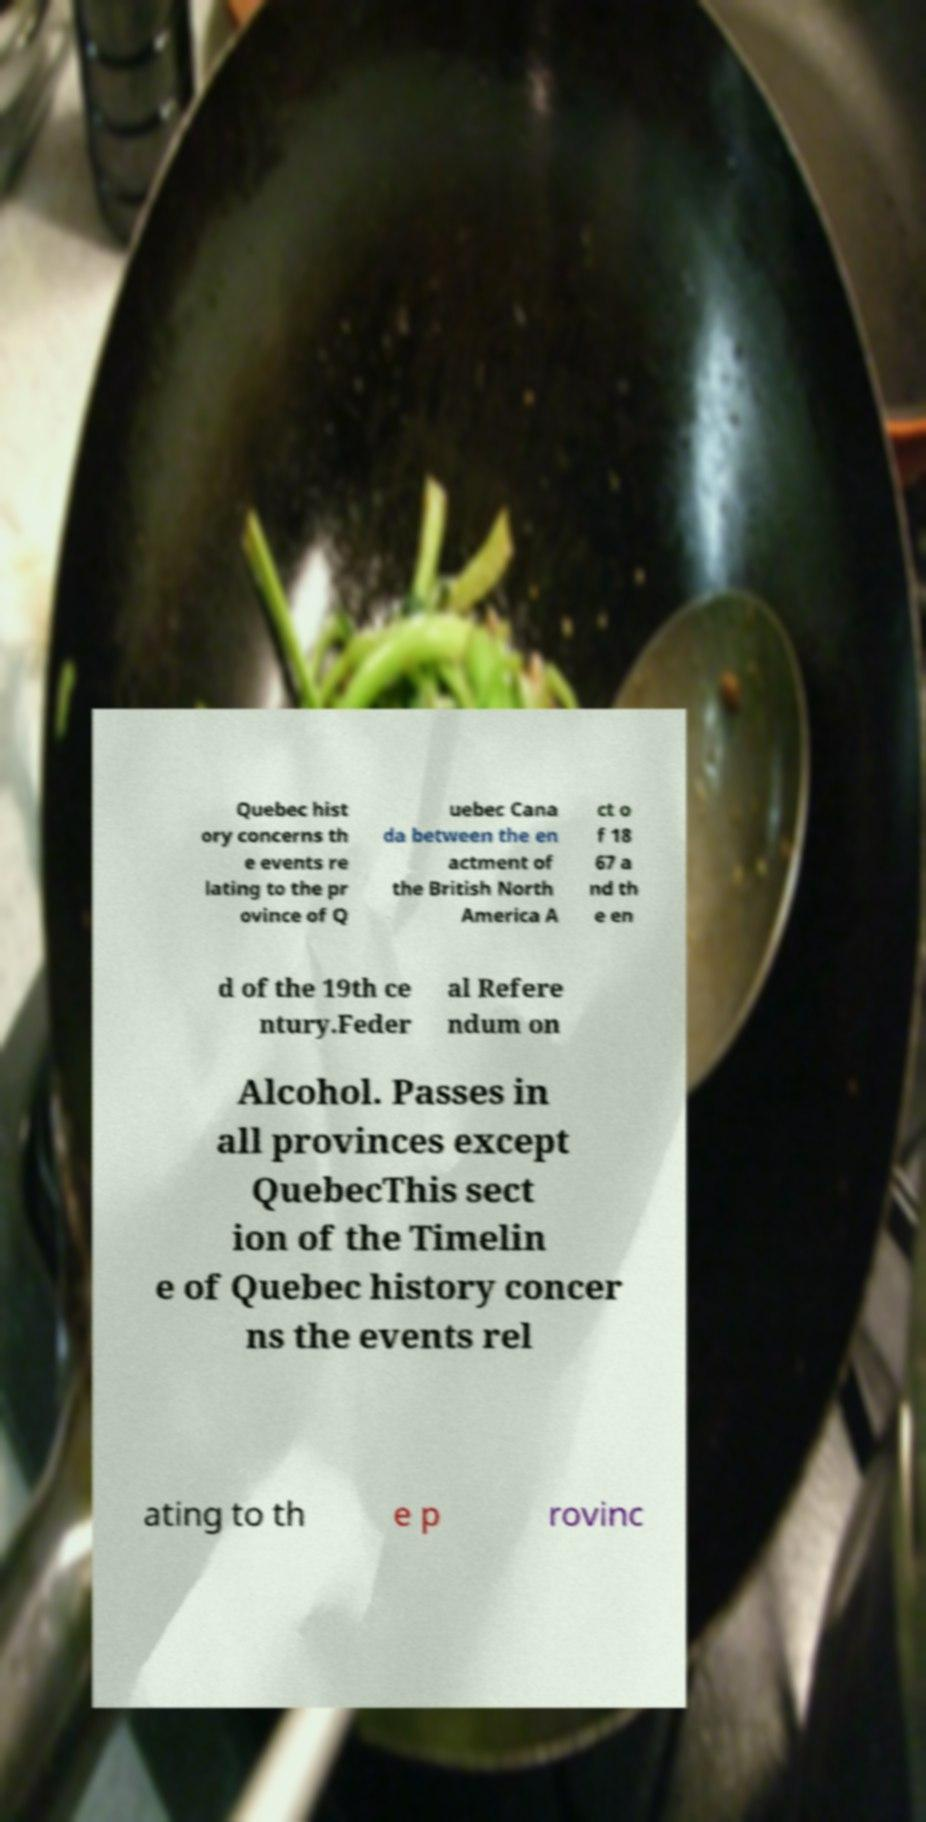Can you read and provide the text displayed in the image?This photo seems to have some interesting text. Can you extract and type it out for me? Quebec hist ory concerns th e events re lating to the pr ovince of Q uebec Cana da between the en actment of the British North America A ct o f 18 67 a nd th e en d of the 19th ce ntury.Feder al Refere ndum on Alcohol. Passes in all provinces except QuebecThis sect ion of the Timelin e of Quebec history concer ns the events rel ating to th e p rovinc 